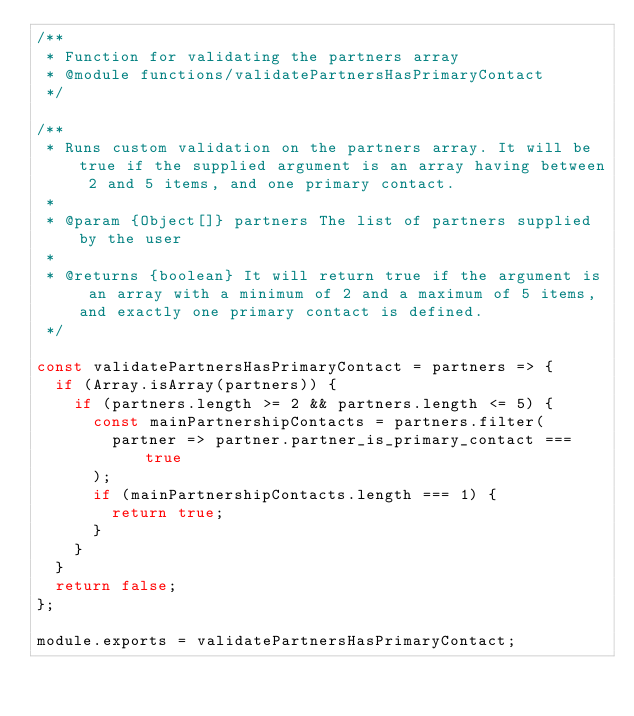Convert code to text. <code><loc_0><loc_0><loc_500><loc_500><_JavaScript_>/**
 * Function for validating the partners array
 * @module functions/validatePartnersHasPrimaryContact
 */

/**
 * Runs custom validation on the partners array. It will be true if the supplied argument is an array having between 2 and 5 items, and one primary contact.
 *
 * @param {Object[]} partners The list of partners supplied by the user
 *
 * @returns {boolean} It will return true if the argument is an array with a minimum of 2 and a maximum of 5 items, and exactly one primary contact is defined.
 */

const validatePartnersHasPrimaryContact = partners => {
  if (Array.isArray(partners)) {
    if (partners.length >= 2 && partners.length <= 5) {
      const mainPartnershipContacts = partners.filter(
        partner => partner.partner_is_primary_contact === true
      );
      if (mainPartnershipContacts.length === 1) {
        return true;
      }
    }
  }
  return false;
};

module.exports = validatePartnersHasPrimaryContact;
</code> 